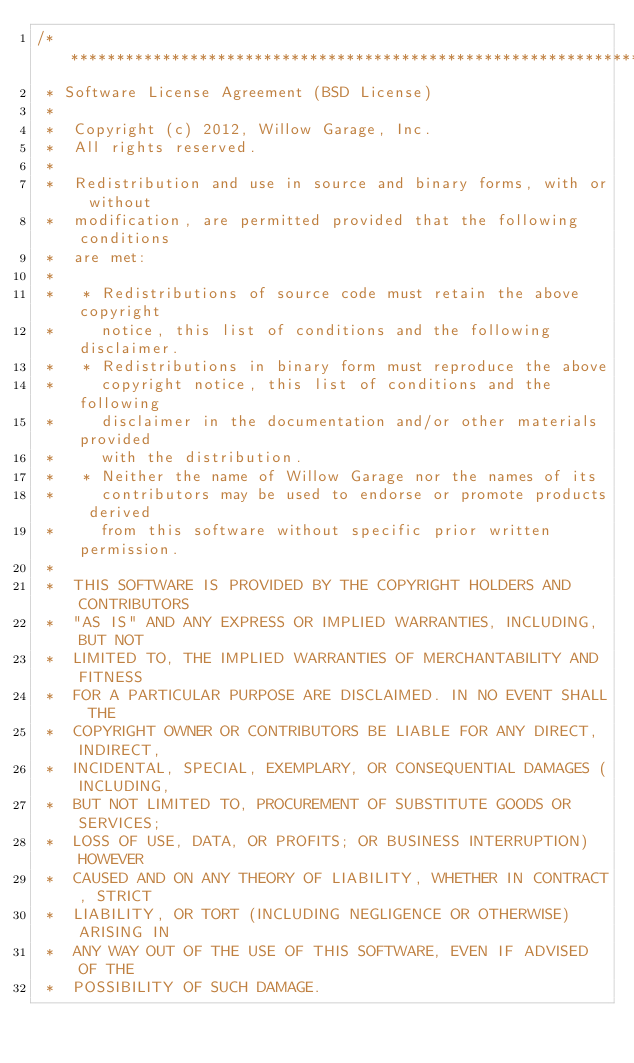<code> <loc_0><loc_0><loc_500><loc_500><_C_>/*********************************************************************
 * Software License Agreement (BSD License)
 *
 *  Copyright (c) 2012, Willow Garage, Inc.
 *  All rights reserved.
 *
 *  Redistribution and use in source and binary forms, with or without
 *  modification, are permitted provided that the following conditions
 *  are met:
 *
 *   * Redistributions of source code must retain the above copyright
 *     notice, this list of conditions and the following disclaimer.
 *   * Redistributions in binary form must reproduce the above
 *     copyright notice, this list of conditions and the following
 *     disclaimer in the documentation and/or other materials provided
 *     with the distribution.
 *   * Neither the name of Willow Garage nor the names of its
 *     contributors may be used to endorse or promote products derived
 *     from this software without specific prior written permission.
 *
 *  THIS SOFTWARE IS PROVIDED BY THE COPYRIGHT HOLDERS AND CONTRIBUTORS
 *  "AS IS" AND ANY EXPRESS OR IMPLIED WARRANTIES, INCLUDING, BUT NOT
 *  LIMITED TO, THE IMPLIED WARRANTIES OF MERCHANTABILITY AND FITNESS
 *  FOR A PARTICULAR PURPOSE ARE DISCLAIMED. IN NO EVENT SHALL THE
 *  COPYRIGHT OWNER OR CONTRIBUTORS BE LIABLE FOR ANY DIRECT, INDIRECT,
 *  INCIDENTAL, SPECIAL, EXEMPLARY, OR CONSEQUENTIAL DAMAGES (INCLUDING,
 *  BUT NOT LIMITED TO, PROCUREMENT OF SUBSTITUTE GOODS OR SERVICES;
 *  LOSS OF USE, DATA, OR PROFITS; OR BUSINESS INTERRUPTION) HOWEVER
 *  CAUSED AND ON ANY THEORY OF LIABILITY, WHETHER IN CONTRACT, STRICT
 *  LIABILITY, OR TORT (INCLUDING NEGLIGENCE OR OTHERWISE) ARISING IN
 *  ANY WAY OUT OF THE USE OF THIS SOFTWARE, EVEN IF ADVISED OF THE
 *  POSSIBILITY OF SUCH DAMAGE.</code> 